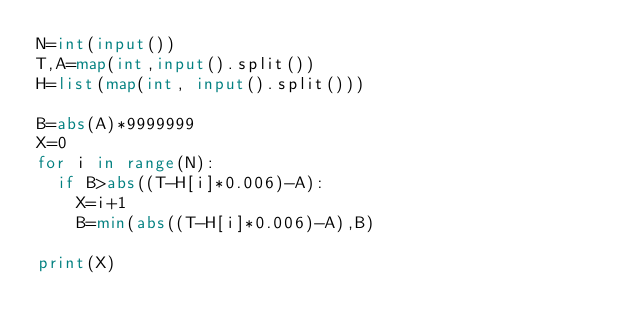Convert code to text. <code><loc_0><loc_0><loc_500><loc_500><_Python_>N=int(input())
T,A=map(int,input().split())
H=list(map(int, input().split()))

B=abs(A)*9999999
X=0
for i in range(N):
  if B>abs((T-H[i]*0.006)-A):
    X=i+1
    B=min(abs((T-H[i]*0.006)-A),B)

print(X)</code> 